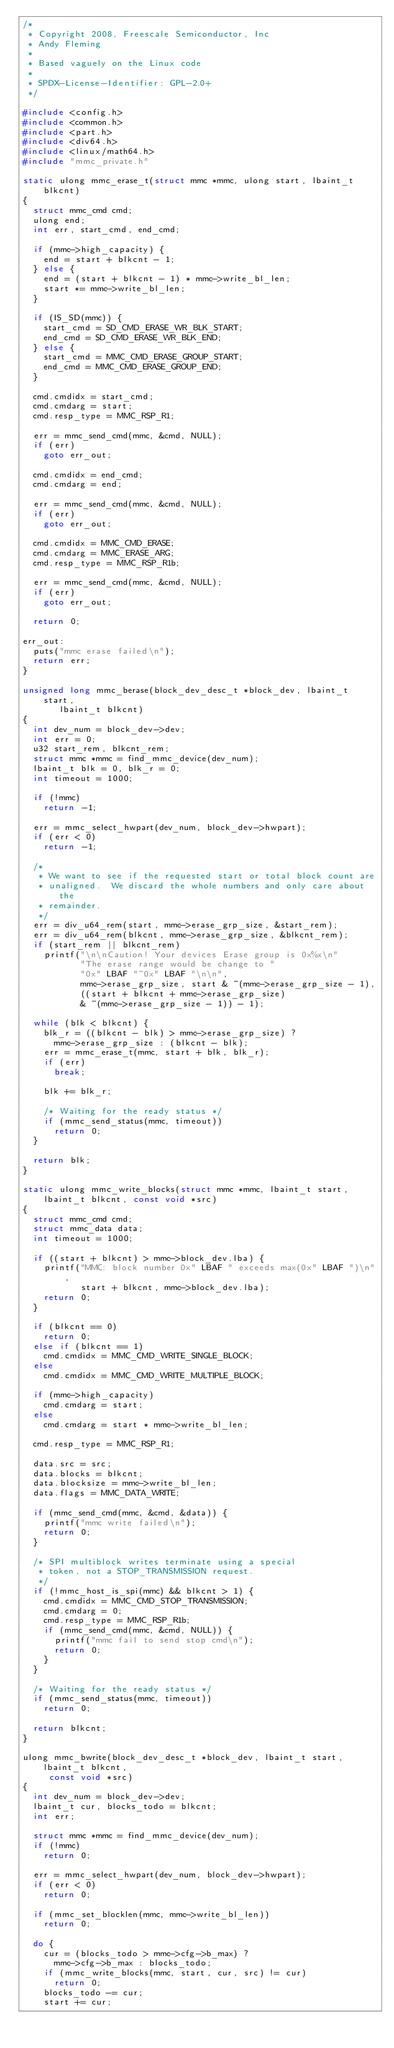Convert code to text. <code><loc_0><loc_0><loc_500><loc_500><_C_>/*
 * Copyright 2008, Freescale Semiconductor, Inc
 * Andy Fleming
 *
 * Based vaguely on the Linux code
 *
 * SPDX-License-Identifier:	GPL-2.0+
 */

#include <config.h>
#include <common.h>
#include <part.h>
#include <div64.h>
#include <linux/math64.h>
#include "mmc_private.h"

static ulong mmc_erase_t(struct mmc *mmc, ulong start, lbaint_t blkcnt)
{
	struct mmc_cmd cmd;
	ulong end;
	int err, start_cmd, end_cmd;

	if (mmc->high_capacity) {
		end = start + blkcnt - 1;
	} else {
		end = (start + blkcnt - 1) * mmc->write_bl_len;
		start *= mmc->write_bl_len;
	}

	if (IS_SD(mmc)) {
		start_cmd = SD_CMD_ERASE_WR_BLK_START;
		end_cmd = SD_CMD_ERASE_WR_BLK_END;
	} else {
		start_cmd = MMC_CMD_ERASE_GROUP_START;
		end_cmd = MMC_CMD_ERASE_GROUP_END;
	}

	cmd.cmdidx = start_cmd;
	cmd.cmdarg = start;
	cmd.resp_type = MMC_RSP_R1;

	err = mmc_send_cmd(mmc, &cmd, NULL);
	if (err)
		goto err_out;

	cmd.cmdidx = end_cmd;
	cmd.cmdarg = end;

	err = mmc_send_cmd(mmc, &cmd, NULL);
	if (err)
		goto err_out;

	cmd.cmdidx = MMC_CMD_ERASE;
	cmd.cmdarg = MMC_ERASE_ARG;
	cmd.resp_type = MMC_RSP_R1b;

	err = mmc_send_cmd(mmc, &cmd, NULL);
	if (err)
		goto err_out;

	return 0;

err_out:
	puts("mmc erase failed\n");
	return err;
}

unsigned long mmc_berase(block_dev_desc_t *block_dev, lbaint_t start,
			 lbaint_t blkcnt)
{
	int dev_num = block_dev->dev;
	int err = 0;
	u32 start_rem, blkcnt_rem;
	struct mmc *mmc = find_mmc_device(dev_num);
	lbaint_t blk = 0, blk_r = 0;
	int timeout = 1000;

	if (!mmc)
		return -1;

	err = mmc_select_hwpart(dev_num, block_dev->hwpart);
	if (err < 0)
		return -1;

	/*
	 * We want to see if the requested start or total block count are
	 * unaligned.  We discard the whole numbers and only care about the
	 * remainder.
	 */
	err = div_u64_rem(start, mmc->erase_grp_size, &start_rem);
	err = div_u64_rem(blkcnt, mmc->erase_grp_size, &blkcnt_rem);
	if (start_rem || blkcnt_rem)
		printf("\n\nCaution! Your devices Erase group is 0x%x\n"
		       "The erase range would be change to "
		       "0x" LBAF "~0x" LBAF "\n\n",
		       mmc->erase_grp_size, start & ~(mmc->erase_grp_size - 1),
		       ((start + blkcnt + mmc->erase_grp_size)
		       & ~(mmc->erase_grp_size - 1)) - 1);

	while (blk < blkcnt) {
		blk_r = ((blkcnt - blk) > mmc->erase_grp_size) ?
			mmc->erase_grp_size : (blkcnt - blk);
		err = mmc_erase_t(mmc, start + blk, blk_r);
		if (err)
			break;

		blk += blk_r;

		/* Waiting for the ready status */
		if (mmc_send_status(mmc, timeout))
			return 0;
	}

	return blk;
}

static ulong mmc_write_blocks(struct mmc *mmc, lbaint_t start,
		lbaint_t blkcnt, const void *src)
{
	struct mmc_cmd cmd;
	struct mmc_data data;
	int timeout = 1000;

	if ((start + blkcnt) > mmc->block_dev.lba) {
		printf("MMC: block number 0x" LBAF " exceeds max(0x" LBAF ")\n",
		       start + blkcnt, mmc->block_dev.lba);
		return 0;
	}

	if (blkcnt == 0)
		return 0;
	else if (blkcnt == 1)
		cmd.cmdidx = MMC_CMD_WRITE_SINGLE_BLOCK;
	else
		cmd.cmdidx = MMC_CMD_WRITE_MULTIPLE_BLOCK;

	if (mmc->high_capacity)
		cmd.cmdarg = start;
	else
		cmd.cmdarg = start * mmc->write_bl_len;

	cmd.resp_type = MMC_RSP_R1;

	data.src = src;
	data.blocks = blkcnt;
	data.blocksize = mmc->write_bl_len;
	data.flags = MMC_DATA_WRITE;

	if (mmc_send_cmd(mmc, &cmd, &data)) {
		printf("mmc write failed\n");
		return 0;
	}

	/* SPI multiblock writes terminate using a special
	 * token, not a STOP_TRANSMISSION request.
	 */
	if (!mmc_host_is_spi(mmc) && blkcnt > 1) {
		cmd.cmdidx = MMC_CMD_STOP_TRANSMISSION;
		cmd.cmdarg = 0;
		cmd.resp_type = MMC_RSP_R1b;
		if (mmc_send_cmd(mmc, &cmd, NULL)) {
			printf("mmc fail to send stop cmd\n");
			return 0;
		}
	}

	/* Waiting for the ready status */
	if (mmc_send_status(mmc, timeout))
		return 0;

	return blkcnt;
}

ulong mmc_bwrite(block_dev_desc_t *block_dev, lbaint_t start, lbaint_t blkcnt,
		 const void *src)
{
	int dev_num = block_dev->dev;
	lbaint_t cur, blocks_todo = blkcnt;
	int err;

	struct mmc *mmc = find_mmc_device(dev_num);
	if (!mmc)
		return 0;

	err = mmc_select_hwpart(dev_num, block_dev->hwpart);
	if (err < 0)
		return 0;

	if (mmc_set_blocklen(mmc, mmc->write_bl_len))
		return 0;

	do {
		cur = (blocks_todo > mmc->cfg->b_max) ?
			mmc->cfg->b_max : blocks_todo;
		if (mmc_write_blocks(mmc, start, cur, src) != cur)
			return 0;
		blocks_todo -= cur;
		start += cur;</code> 